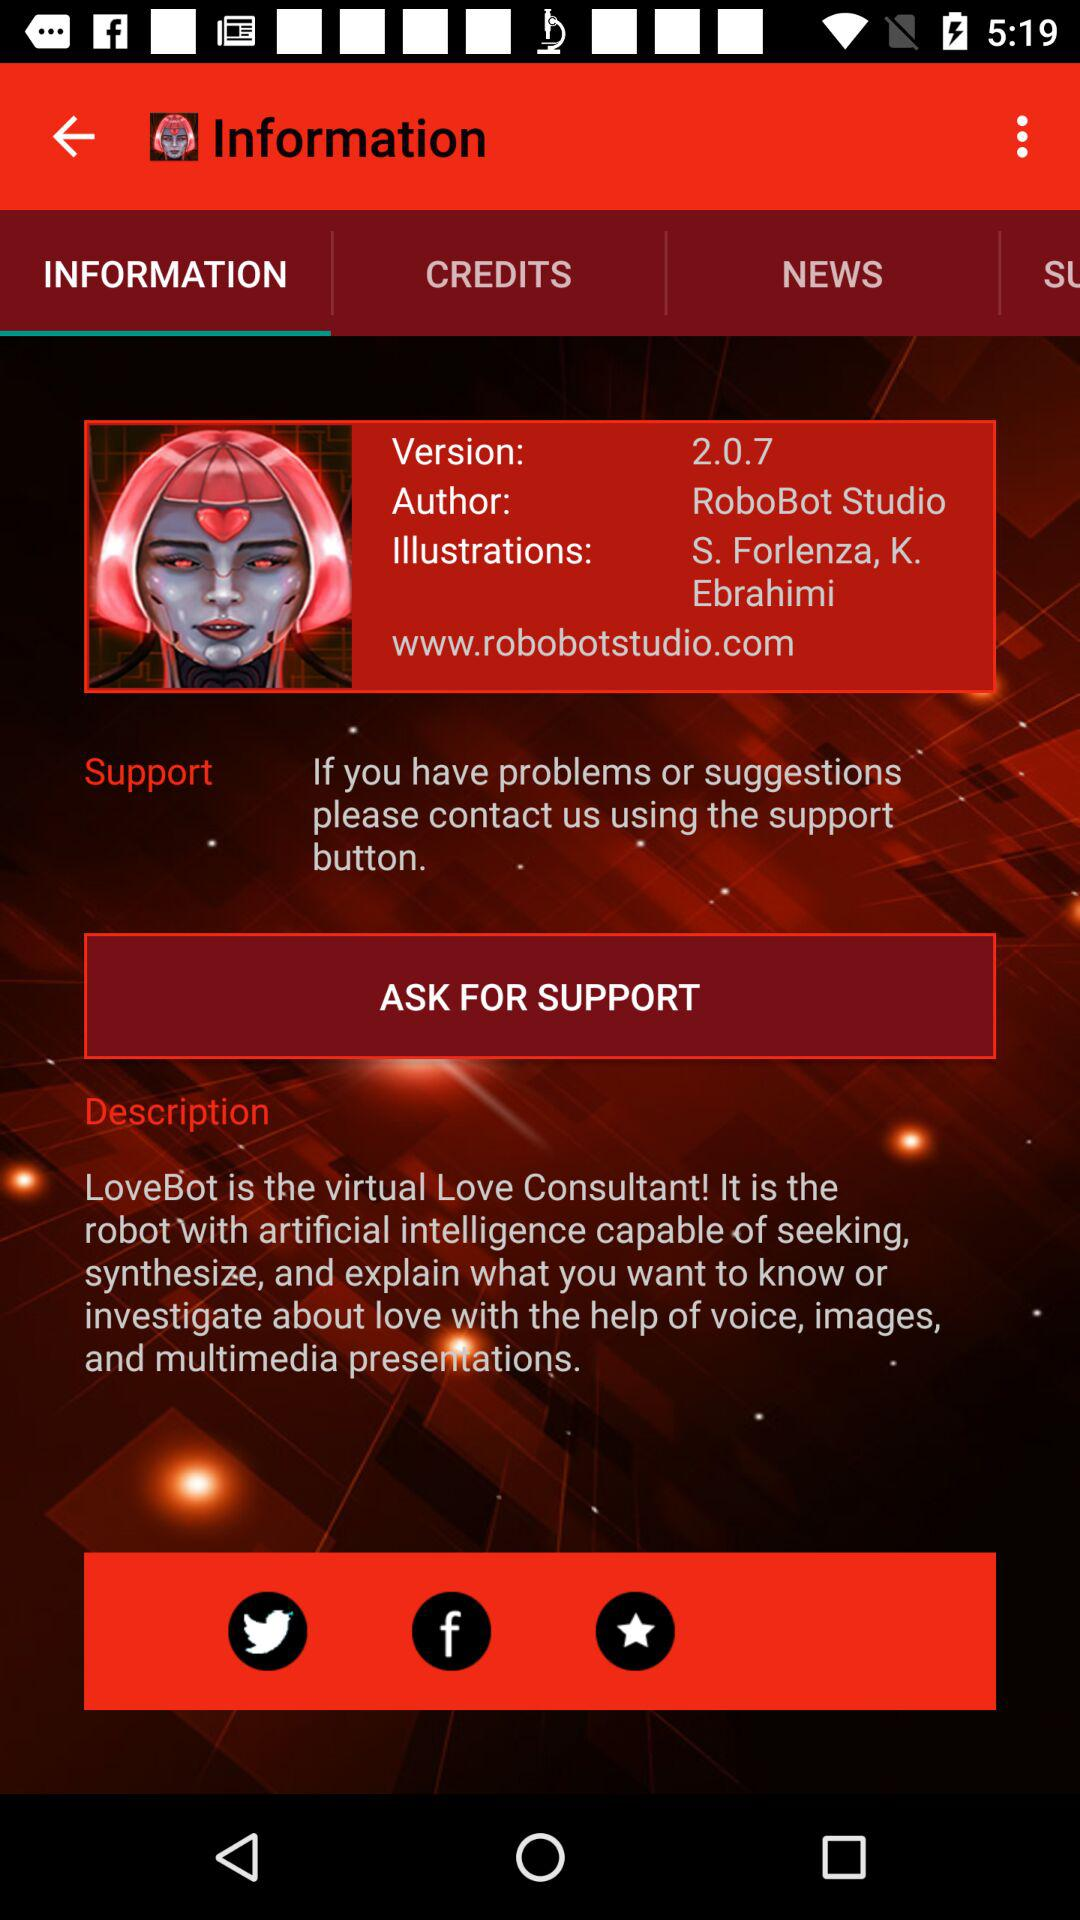Which tab is selected? The selected tab is "INFORMATION". 